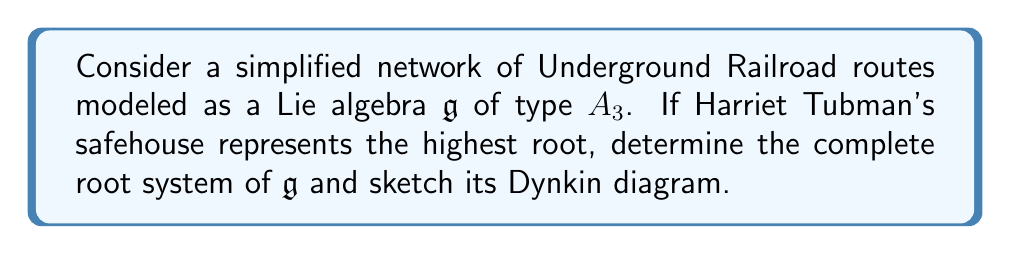Could you help me with this problem? To solve this problem, we'll follow these steps:

1) Recall that the Lie algebra of type $A_3$ corresponds to $\mathfrak{sl}(4, \mathbb{C})$, the special linear algebra of $4 \times 4$ complex matrices with trace zero.

2) The root system of $A_3$ consists of 12 roots:
   $$\{\pm(\epsilon_i - \epsilon_j) \mid 1 \leq i < j \leq 4\}$$
   where $\epsilon_i$ are the standard basis vectors in $\mathbb{R}^4$.

3) The highest root in this system is $\alpha_h = \epsilon_1 - \epsilon_4 = (\alpha_1 + \alpha_2 + \alpha_3)$, where $\alpha_1, \alpha_2, \alpha_3$ are the simple roots.

4) The simple roots can be expressed as:
   $$\alpha_1 = \epsilon_1 - \epsilon_2$$
   $$\alpha_2 = \epsilon_2 - \epsilon_3$$
   $$\alpha_3 = \epsilon_3 - \epsilon_4$$

5) The complete set of positive roots is:
   $$\alpha_1, \alpha_2, \alpha_3, \alpha_1 + \alpha_2, \alpha_2 + \alpha_3, \alpha_1 + \alpha_2 + \alpha_3$$

6) The negative roots are just the negatives of these.

7) The Dynkin diagram for $A_3$ is a line with three nodes, representing the simple roots:

   [asy]
   unitsize(1cm);
   dot((0,0)); dot((1,0)); dot((2,0));
   draw((0,0)--(2,0));
   label("$\alpha_1$", (0,-0.5));
   label("$\alpha_2$", (1,-0.5));
   label("$\alpha_3$", (2,-0.5));
   [/asy]

8) In the context of the Underground Railroad, we can interpret each positive root as a possible route, with the highest root ($\alpha_1 + \alpha_2 + \alpha_3$) representing Harriet Tubman's safehouse, which connects the start ($\epsilon_1$) to the final destination ($\epsilon_4$).
Answer: The complete root system of $\mathfrak{g}$ is:
$$\{\pm(\epsilon_1 - \epsilon_2), \pm(\epsilon_2 - \epsilon_3), \pm(\epsilon_3 - \epsilon_4), \pm(\epsilon_1 - \epsilon_3), \pm(\epsilon_2 - \epsilon_4), \pm(\epsilon_1 - \epsilon_4)\}$$
The Dynkin diagram is a line with three nodes representing $\alpha_1, \alpha_2, \alpha_3$. 